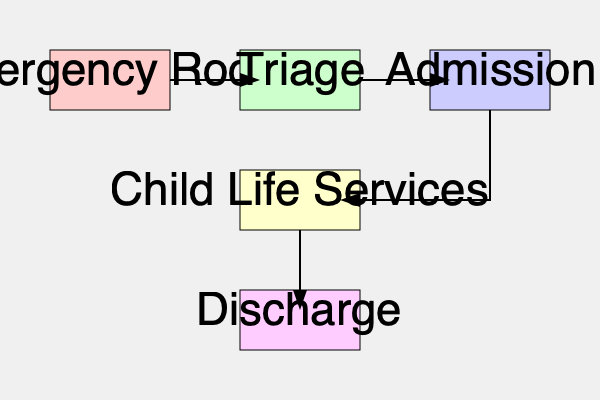In the patient journey flowchart, at which stage does the Child Life Services typically intervene to support pediatric patients? To answer this question, we need to analyze the flowchart depicting the patient journey through different hospital services:

1. The journey starts at the Emergency Room, which is the entry point for many pediatric patients.
2. From the Emergency Room, patients move to Triage, where their medical needs are assessed and prioritized.
3. After Triage, patients who require further care are moved to the Admission stage.
4. Following Admission, there's an arrow pointing to Child Life Services.
5. Child Life Services is positioned between Admission and Discharge, indicating that it occurs during the patient's hospital stay.
6. The flowchart shows that Child Life Services intervene after the patient has been admitted to the hospital.

Therefore, based on this flowchart, Child Life Services typically become involved after the patient has gone through the Admission process, but before they are discharged.
Answer: After Admission 